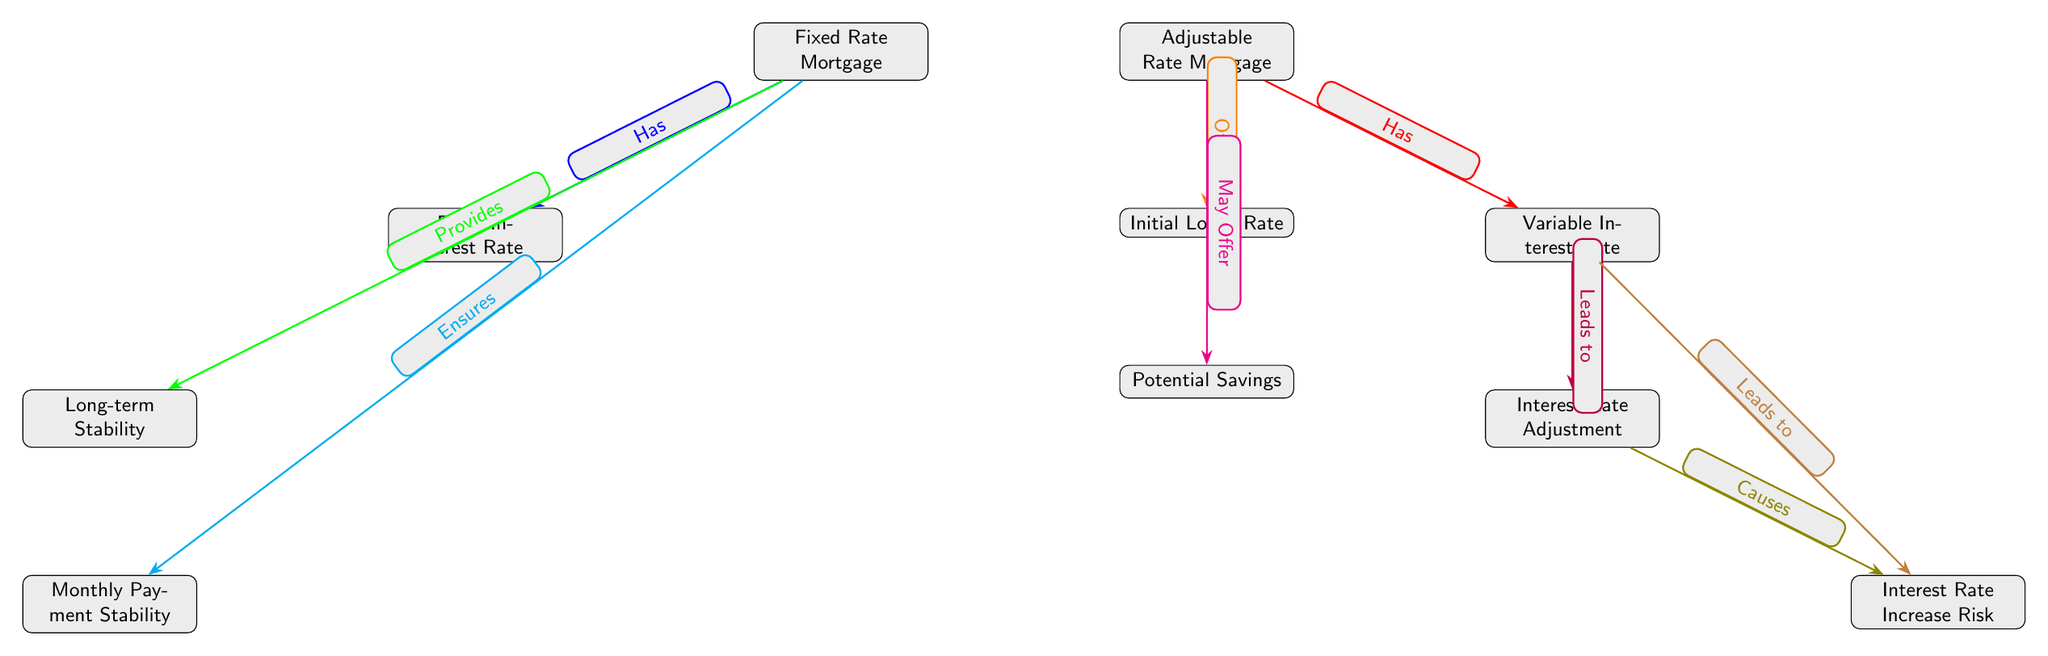What are the two main types of mortgages in the diagram? The diagram clearly identifies two main types of mortgages, which are represented as the first two nodes: "Fixed Rate Mortgage" and "Adjustable Rate Mortgage."
Answer: Fixed Rate Mortgage, Adjustable Rate Mortgage What does a Fixed Rate Mortgage offer for long-term financial stability? The diagram shows a connection from "Fixed Rate Mortgage" to "Long-term Stability," indicating that it ensures stability over time due to fixed rates.
Answer: Long-term Stability What is the risk associated with an Adjustable Rate Mortgage as indicated in the diagram? The diagram shows that "Variable Interest Rate" leads to "Interest Rate Increase Risk," suggesting that an Adjustable Rate Mortgage has an associated risk of increasing interest rates.
Answer: Interest Rate Increase Risk How many nodes are there in the diagram? The diagram consists of a total of 9 nodes including the main types of mortgages and their related implications.
Answer: 9 What feature may an Adjustable Rate Mortgage offer according to the diagram? The diagram connects "Adjustable Rate Mortgage" to "Potential Savings," implying that it may provide savings compared to fixed options.
Answer: Potential Savings What does a Fixed Interest Rate lead to as per the diagram? The diagram shows that "Fixed Interest Rate" connects to "Long-term Stability," indicating a direct relation where fixed rates contribute to stability over time.
Answer: Long-term Stability Which type of mortgage ensures monthly payment stability? The diagram indicates that "Fixed Rate Mortgage" has a direct link to "Monthly Payment Stability," confirming this characteristic.
Answer: Monthly Payment Stability Which feature might an Adjustable Rate Mortgage initially provide? The diagram shows a connection stating "Offers" leading from "Adjustable Rate Mortgage" to "Initial Lower Rate," suggesting it might start with a lower rate.
Answer: Initial Lower Rate What leads to an Interest Rate Adjustment in the diagram? Following the flow from "Variable Interest Rate," the diagram indicates it connects to "Interest Rate Adjustment," demonstrating the nature of adjustments in variable rates.
Answer: Interest Rate Adjustment 